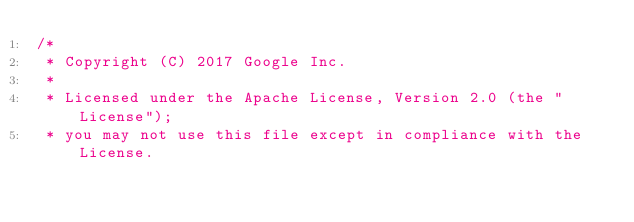<code> <loc_0><loc_0><loc_500><loc_500><_Kotlin_>/*
 * Copyright (C) 2017 Google Inc.
 *
 * Licensed under the Apache License, Version 2.0 (the "License");
 * you may not use this file except in compliance with the License.</code> 